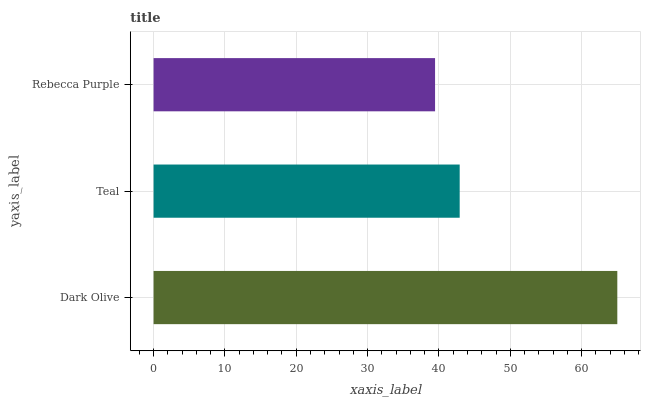Is Rebecca Purple the minimum?
Answer yes or no. Yes. Is Dark Olive the maximum?
Answer yes or no. Yes. Is Teal the minimum?
Answer yes or no. No. Is Teal the maximum?
Answer yes or no. No. Is Dark Olive greater than Teal?
Answer yes or no. Yes. Is Teal less than Dark Olive?
Answer yes or no. Yes. Is Teal greater than Dark Olive?
Answer yes or no. No. Is Dark Olive less than Teal?
Answer yes or no. No. Is Teal the high median?
Answer yes or no. Yes. Is Teal the low median?
Answer yes or no. Yes. Is Rebecca Purple the high median?
Answer yes or no. No. Is Dark Olive the low median?
Answer yes or no. No. 